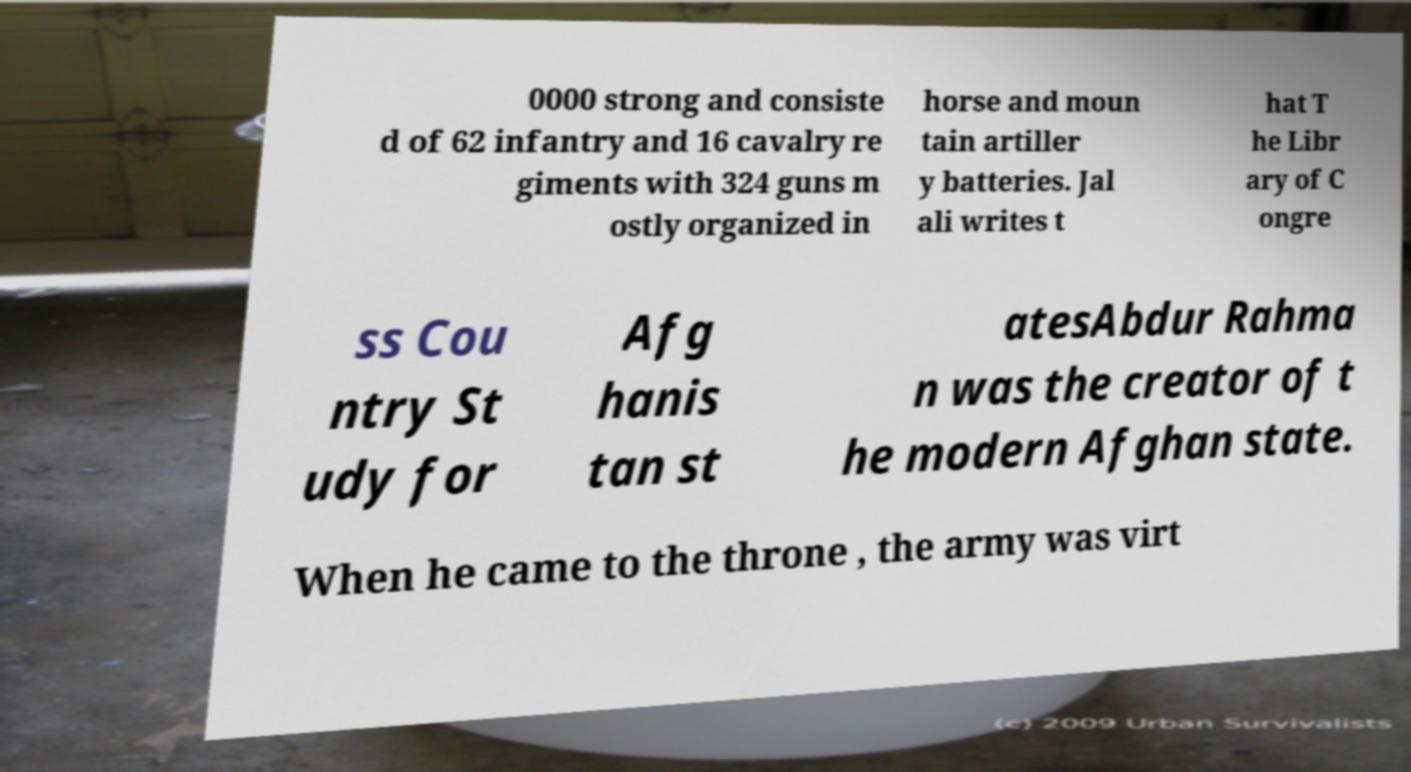Could you assist in decoding the text presented in this image and type it out clearly? 0000 strong and consiste d of 62 infantry and 16 cavalry re giments with 324 guns m ostly organized in horse and moun tain artiller y batteries. Jal ali writes t hat T he Libr ary of C ongre ss Cou ntry St udy for Afg hanis tan st atesAbdur Rahma n was the creator of t he modern Afghan state. When he came to the throne , the army was virt 